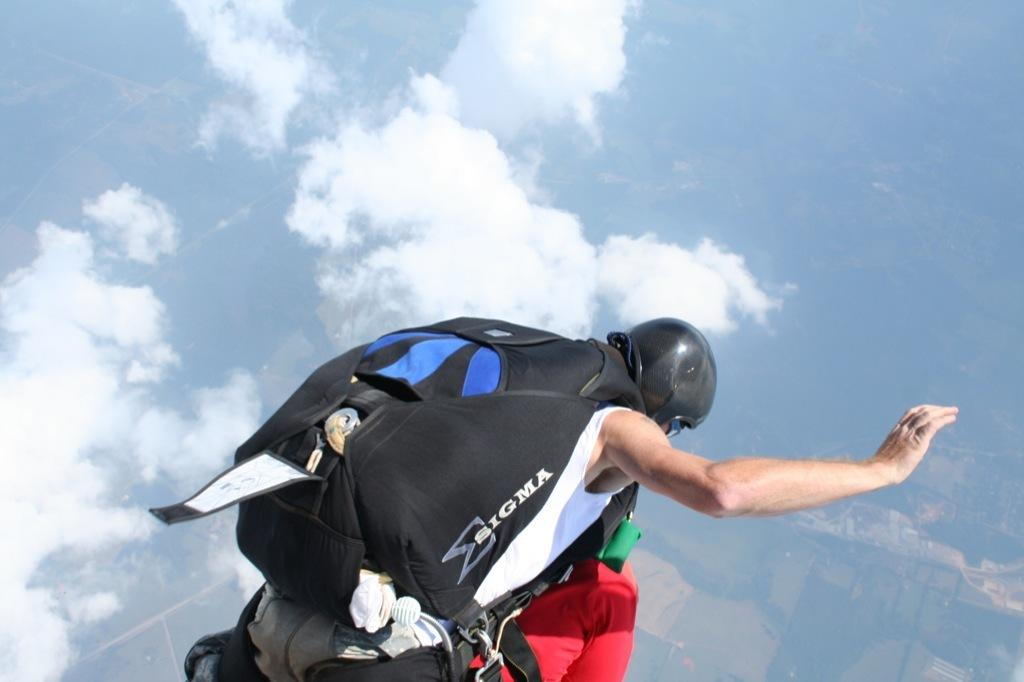What is the main activity being performed by the person in the image? The person is skydiving in the image. What is the person wearing while skydiving? The person is wearing a bag. What can be seen in the sky in the image? There are clouds visible in the sky. What type of bells can be heard ringing in the image? There are no bells present in the image, and therefore no sound can be heard. 